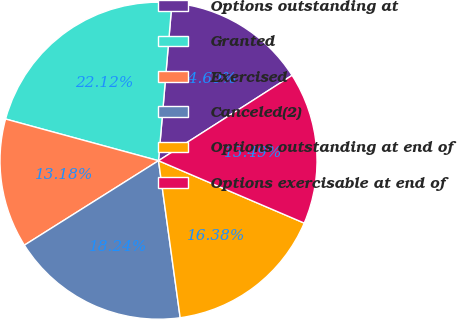<chart> <loc_0><loc_0><loc_500><loc_500><pie_chart><fcel>Options outstanding at<fcel>Granted<fcel>Exercised<fcel>Canceled(2)<fcel>Options outstanding at end of<fcel>Options exercisable at end of<nl><fcel>14.6%<fcel>22.12%<fcel>13.18%<fcel>18.24%<fcel>16.38%<fcel>15.49%<nl></chart> 